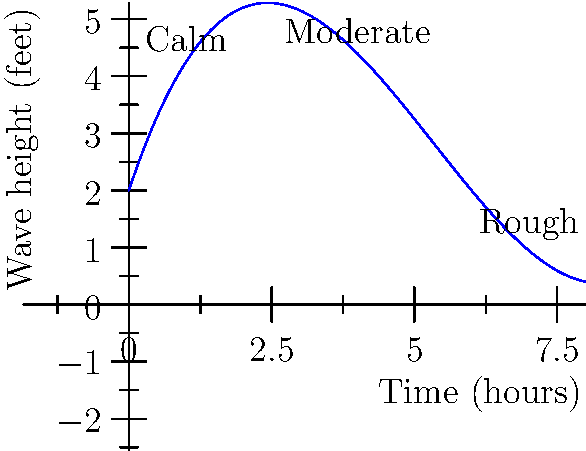The graph above represents a polynomial function modeling wave height during different weather conditions over time. The function is given by $f(x) = 0.05x^3 - 0.8x^2 + 3x + 2$, where $x$ is time in hours and $f(x)$ is wave height in feet. At what time does the wave height reach its minimum during the 8-hour period shown? To find the minimum wave height, we need to follow these steps:

1) The minimum point occurs where the derivative of the function equals zero. Let's find the derivative:

   $f'(x) = 0.15x^2 - 1.6x + 3$

2) Set the derivative equal to zero and solve for x:

   $0.15x^2 - 1.6x + 3 = 0$

3) This is a quadratic equation. We can solve it using the quadratic formula:

   $x = \frac{-b \pm \sqrt{b^2 - 4ac}}{2a}$

   Where $a = 0.15$, $b = -1.6$, and $c = 3$

4) Plugging in these values:

   $x = \frac{1.6 \pm \sqrt{(-1.6)^2 - 4(0.15)(3)}}{2(0.15)}$

5) Simplifying:

   $x = \frac{1.6 \pm \sqrt{2.56 - 1.8}}{0.3} = \frac{1.6 \pm \sqrt{0.76}}{0.3}$

6) This gives us two solutions:

   $x_1 \approx 5.33$ and $x_2 \approx 2.67$

7) Since we're looking for the minimum within the 8-hour period shown, $x \approx 5.33$ is our answer.

Therefore, the wave height reaches its minimum approximately 5.33 hours into the period shown.
Answer: 5.33 hours 